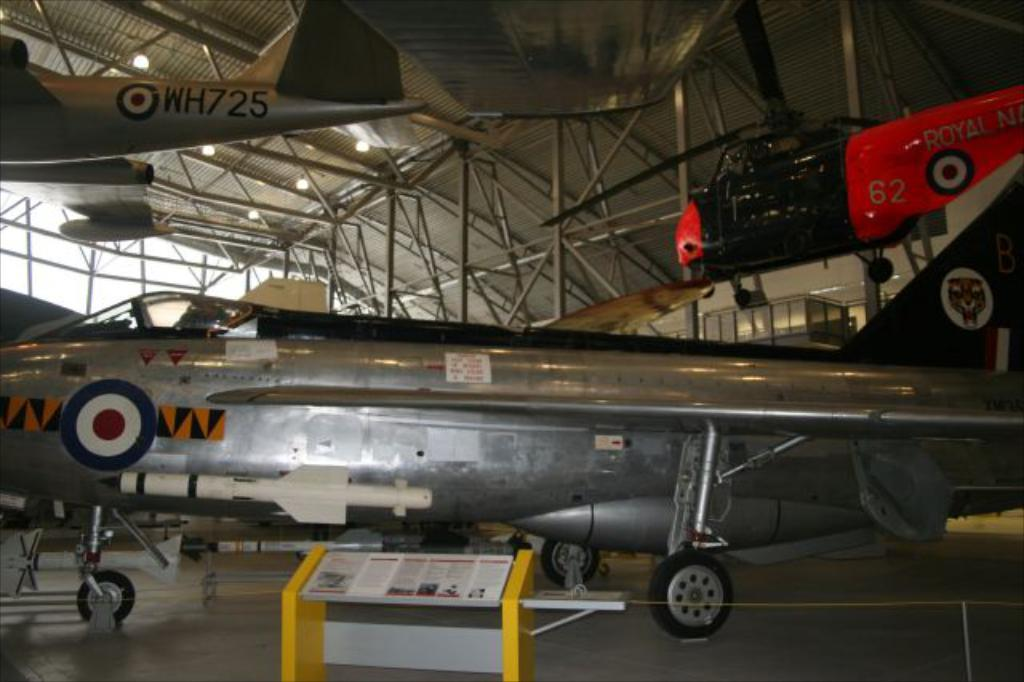<image>
Share a concise interpretation of the image provided. a plane with WH725 on its tail hangs from a hangar with other planes 